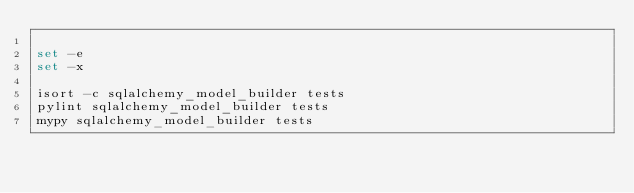<code> <loc_0><loc_0><loc_500><loc_500><_Bash_>
set -e
set -x

isort -c sqlalchemy_model_builder tests
pylint sqlalchemy_model_builder tests
mypy sqlalchemy_model_builder tests
</code> 